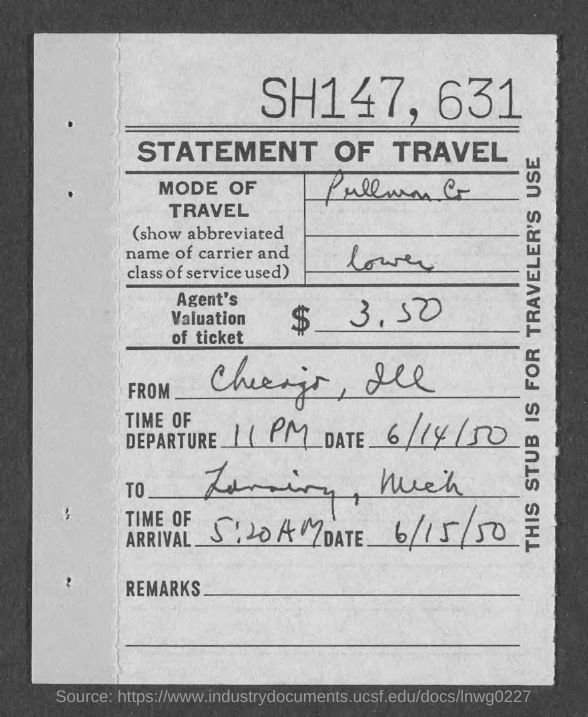Point out several critical features in this image. The agent has valued the ticket at $3.50. On what date will you be departing? Your departure date is 6/14/50. The date of arrival is June 15th, 1950. The text at the top of the page contains the numbers SH147 and 631. The time of departure is 11 PM. 